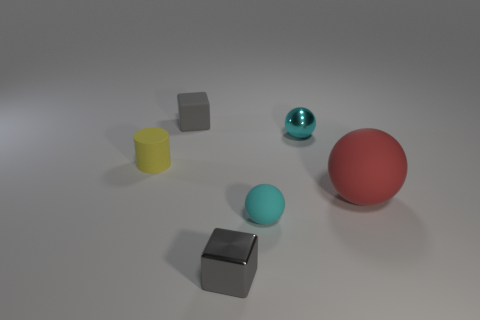Is the color of the tiny thing that is left of the tiny gray matte object the same as the small shiny block?
Give a very brief answer. No. Do the gray rubber block and the yellow rubber cylinder have the same size?
Provide a succinct answer. Yes. There is a gray rubber object that is the same size as the matte cylinder; what shape is it?
Keep it short and to the point. Cube. Do the red matte object that is to the right of the matte block and the cyan metallic ball have the same size?
Offer a very short reply. No. What is the material of the gray thing that is the same size as the shiny block?
Provide a short and direct response. Rubber. Are there any tiny yellow things that are on the left side of the small gray block behind the tiny metal object behind the gray metallic cube?
Give a very brief answer. Yes. Is there any other thing that is the same shape as the large red matte thing?
Ensure brevity in your answer.  Yes. There is a tiny cube that is behind the small cyan metal ball; is its color the same as the cube to the right of the rubber block?
Keep it short and to the point. Yes. Are there any purple metal cylinders?
Your answer should be very brief. No. There is a small object that is the same color as the metal ball; what material is it?
Offer a terse response. Rubber. 